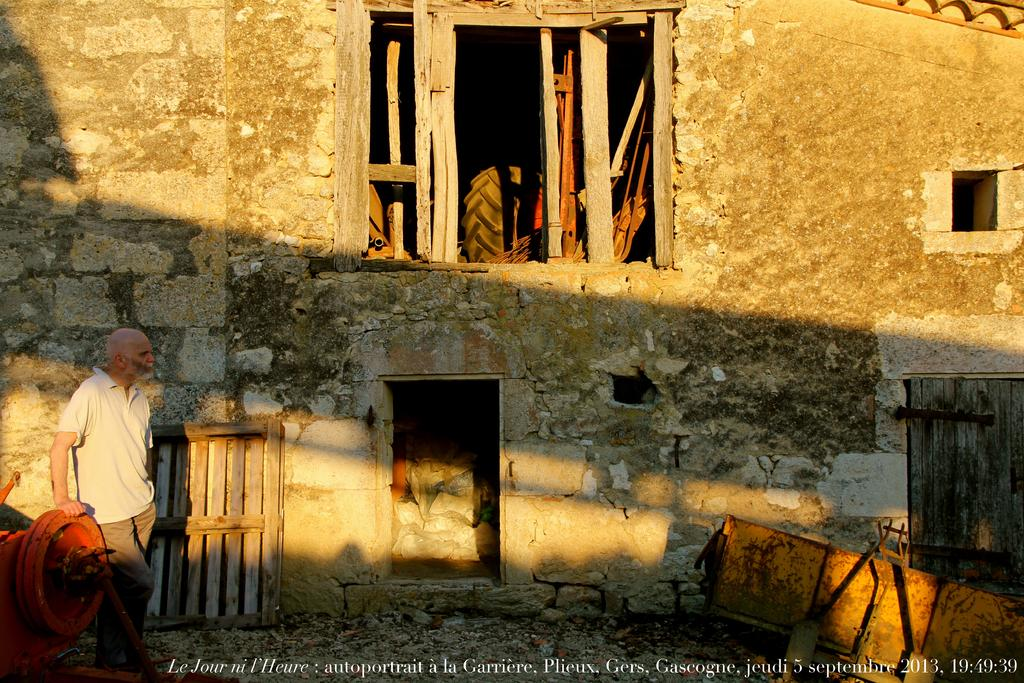<image>
Write a terse but informative summary of the picture. A sunlit, rustic building with the date of 5 September along the botttom 